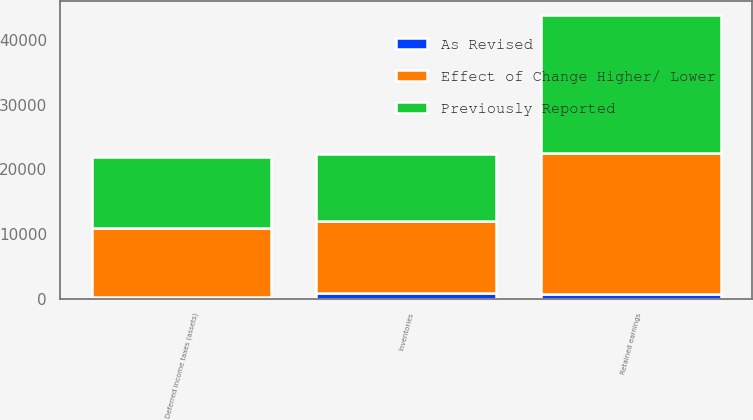Convert chart. <chart><loc_0><loc_0><loc_500><loc_500><stacked_bar_chart><ecel><fcel>Inventories<fcel>Deferred income taxes (assets)<fcel>Retained earnings<nl><fcel>Previously Reported<fcel>10277<fcel>10973<fcel>21218<nl><fcel>Effect of Change Higher/ Lower<fcel>11176<fcel>10762<fcel>21906<nl><fcel>As Revised<fcel>899<fcel>211<fcel>688<nl></chart> 